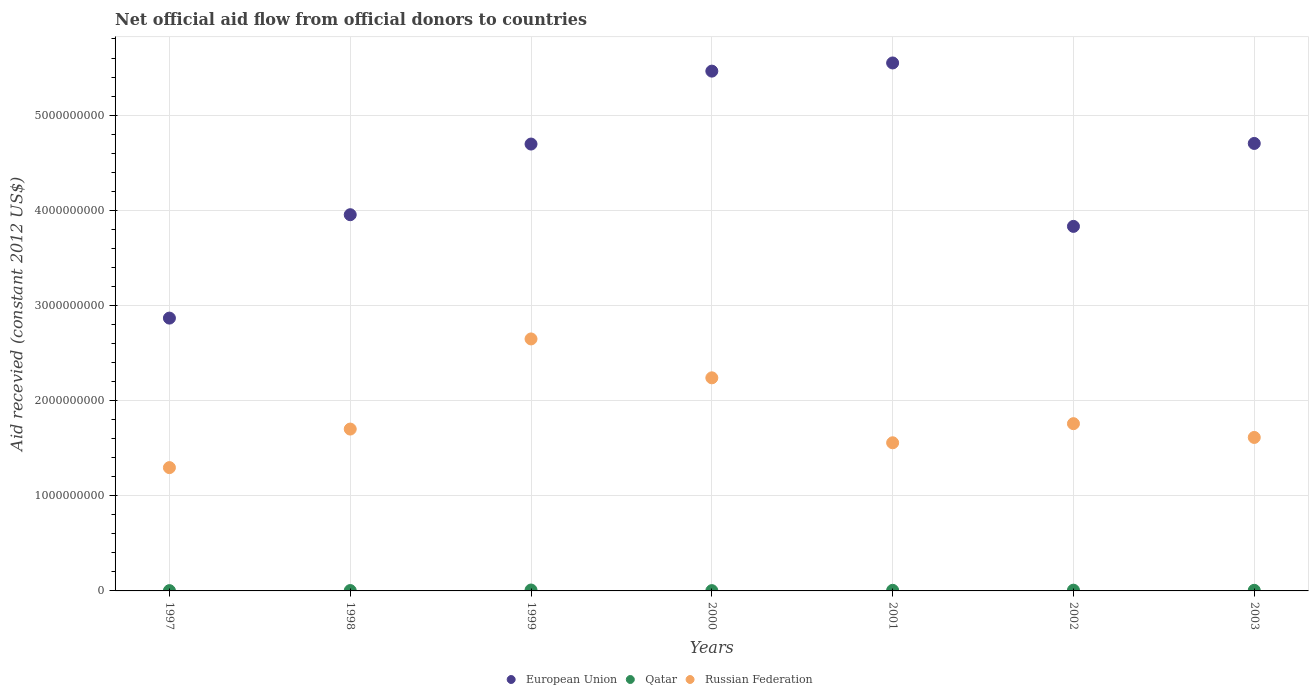What is the total aid received in Qatar in 2000?
Your answer should be compact. 3.14e+06. Across all years, what is the maximum total aid received in Russian Federation?
Provide a succinct answer. 2.65e+09. Across all years, what is the minimum total aid received in European Union?
Offer a very short reply. 2.87e+09. In which year was the total aid received in European Union maximum?
Keep it short and to the point. 2001. In which year was the total aid received in European Union minimum?
Keep it short and to the point. 1997. What is the total total aid received in Russian Federation in the graph?
Your answer should be very brief. 1.28e+1. What is the difference between the total aid received in Qatar in 2002 and that in 2003?
Give a very brief answer. 1.41e+06. What is the difference between the total aid received in Qatar in 1998 and the total aid received in European Union in 2003?
Offer a very short reply. -4.70e+09. What is the average total aid received in Russian Federation per year?
Offer a terse response. 1.83e+09. In the year 2002, what is the difference between the total aid received in European Union and total aid received in Qatar?
Make the answer very short. 3.82e+09. In how many years, is the total aid received in European Union greater than 1600000000 US$?
Provide a short and direct response. 7. What is the ratio of the total aid received in European Union in 1998 to that in 2003?
Provide a succinct answer. 0.84. Is the difference between the total aid received in European Union in 1997 and 1998 greater than the difference between the total aid received in Qatar in 1997 and 1998?
Make the answer very short. No. What is the difference between the highest and the second highest total aid received in European Union?
Offer a very short reply. 8.58e+07. What is the difference between the highest and the lowest total aid received in Qatar?
Provide a short and direct response. 6.53e+06. In how many years, is the total aid received in European Union greater than the average total aid received in European Union taken over all years?
Your response must be concise. 4. Is the sum of the total aid received in Russian Federation in 2001 and 2003 greater than the maximum total aid received in Qatar across all years?
Offer a very short reply. Yes. Does the total aid received in Qatar monotonically increase over the years?
Give a very brief answer. No. Is the total aid received in Russian Federation strictly greater than the total aid received in Qatar over the years?
Keep it short and to the point. Yes. Is the total aid received in Russian Federation strictly less than the total aid received in European Union over the years?
Offer a very short reply. Yes. How many years are there in the graph?
Your answer should be compact. 7. Are the values on the major ticks of Y-axis written in scientific E-notation?
Provide a succinct answer. No. Does the graph contain grids?
Offer a very short reply. Yes. How many legend labels are there?
Ensure brevity in your answer.  3. How are the legend labels stacked?
Your answer should be very brief. Horizontal. What is the title of the graph?
Make the answer very short. Net official aid flow from official donors to countries. What is the label or title of the X-axis?
Keep it short and to the point. Years. What is the label or title of the Y-axis?
Give a very brief answer. Aid recevied (constant 2012 US$). What is the Aid recevied (constant 2012 US$) in European Union in 1997?
Keep it short and to the point. 2.87e+09. What is the Aid recevied (constant 2012 US$) in Qatar in 1997?
Offer a very short reply. 2.98e+06. What is the Aid recevied (constant 2012 US$) in Russian Federation in 1997?
Offer a terse response. 1.30e+09. What is the Aid recevied (constant 2012 US$) of European Union in 1998?
Your response must be concise. 3.95e+09. What is the Aid recevied (constant 2012 US$) of Qatar in 1998?
Provide a succinct answer. 3.90e+06. What is the Aid recevied (constant 2012 US$) in Russian Federation in 1998?
Offer a very short reply. 1.70e+09. What is the Aid recevied (constant 2012 US$) in European Union in 1999?
Provide a succinct answer. 4.70e+09. What is the Aid recevied (constant 2012 US$) in Qatar in 1999?
Keep it short and to the point. 9.51e+06. What is the Aid recevied (constant 2012 US$) of Russian Federation in 1999?
Provide a succinct answer. 2.65e+09. What is the Aid recevied (constant 2012 US$) in European Union in 2000?
Make the answer very short. 5.46e+09. What is the Aid recevied (constant 2012 US$) in Qatar in 2000?
Provide a short and direct response. 3.14e+06. What is the Aid recevied (constant 2012 US$) in Russian Federation in 2000?
Your response must be concise. 2.24e+09. What is the Aid recevied (constant 2012 US$) of European Union in 2001?
Offer a very short reply. 5.55e+09. What is the Aid recevied (constant 2012 US$) of Qatar in 2001?
Your answer should be compact. 6.30e+06. What is the Aid recevied (constant 2012 US$) of Russian Federation in 2001?
Offer a terse response. 1.56e+09. What is the Aid recevied (constant 2012 US$) in European Union in 2002?
Keep it short and to the point. 3.83e+09. What is the Aid recevied (constant 2012 US$) of Qatar in 2002?
Your answer should be very brief. 7.79e+06. What is the Aid recevied (constant 2012 US$) in Russian Federation in 2002?
Your answer should be very brief. 1.76e+09. What is the Aid recevied (constant 2012 US$) of European Union in 2003?
Your answer should be compact. 4.70e+09. What is the Aid recevied (constant 2012 US$) of Qatar in 2003?
Give a very brief answer. 6.38e+06. What is the Aid recevied (constant 2012 US$) of Russian Federation in 2003?
Ensure brevity in your answer.  1.61e+09. Across all years, what is the maximum Aid recevied (constant 2012 US$) of European Union?
Your answer should be very brief. 5.55e+09. Across all years, what is the maximum Aid recevied (constant 2012 US$) in Qatar?
Your response must be concise. 9.51e+06. Across all years, what is the maximum Aid recevied (constant 2012 US$) in Russian Federation?
Keep it short and to the point. 2.65e+09. Across all years, what is the minimum Aid recevied (constant 2012 US$) in European Union?
Your response must be concise. 2.87e+09. Across all years, what is the minimum Aid recevied (constant 2012 US$) of Qatar?
Keep it short and to the point. 2.98e+06. Across all years, what is the minimum Aid recevied (constant 2012 US$) in Russian Federation?
Offer a very short reply. 1.30e+09. What is the total Aid recevied (constant 2012 US$) of European Union in the graph?
Your response must be concise. 3.11e+1. What is the total Aid recevied (constant 2012 US$) of Qatar in the graph?
Offer a very short reply. 4.00e+07. What is the total Aid recevied (constant 2012 US$) in Russian Federation in the graph?
Your answer should be compact. 1.28e+1. What is the difference between the Aid recevied (constant 2012 US$) in European Union in 1997 and that in 1998?
Make the answer very short. -1.09e+09. What is the difference between the Aid recevied (constant 2012 US$) of Qatar in 1997 and that in 1998?
Keep it short and to the point. -9.20e+05. What is the difference between the Aid recevied (constant 2012 US$) in Russian Federation in 1997 and that in 1998?
Your answer should be very brief. -4.05e+08. What is the difference between the Aid recevied (constant 2012 US$) in European Union in 1997 and that in 1999?
Offer a very short reply. -1.83e+09. What is the difference between the Aid recevied (constant 2012 US$) in Qatar in 1997 and that in 1999?
Keep it short and to the point. -6.53e+06. What is the difference between the Aid recevied (constant 2012 US$) of Russian Federation in 1997 and that in 1999?
Give a very brief answer. -1.35e+09. What is the difference between the Aid recevied (constant 2012 US$) of European Union in 1997 and that in 2000?
Keep it short and to the point. -2.60e+09. What is the difference between the Aid recevied (constant 2012 US$) of Qatar in 1997 and that in 2000?
Make the answer very short. -1.60e+05. What is the difference between the Aid recevied (constant 2012 US$) in Russian Federation in 1997 and that in 2000?
Give a very brief answer. -9.44e+08. What is the difference between the Aid recevied (constant 2012 US$) in European Union in 1997 and that in 2001?
Provide a succinct answer. -2.68e+09. What is the difference between the Aid recevied (constant 2012 US$) of Qatar in 1997 and that in 2001?
Your answer should be compact. -3.32e+06. What is the difference between the Aid recevied (constant 2012 US$) of Russian Federation in 1997 and that in 2001?
Your response must be concise. -2.61e+08. What is the difference between the Aid recevied (constant 2012 US$) of European Union in 1997 and that in 2002?
Make the answer very short. -9.64e+08. What is the difference between the Aid recevied (constant 2012 US$) of Qatar in 1997 and that in 2002?
Your response must be concise. -4.81e+06. What is the difference between the Aid recevied (constant 2012 US$) in Russian Federation in 1997 and that in 2002?
Keep it short and to the point. -4.62e+08. What is the difference between the Aid recevied (constant 2012 US$) of European Union in 1997 and that in 2003?
Your answer should be very brief. -1.84e+09. What is the difference between the Aid recevied (constant 2012 US$) in Qatar in 1997 and that in 2003?
Provide a succinct answer. -3.40e+06. What is the difference between the Aid recevied (constant 2012 US$) in Russian Federation in 1997 and that in 2003?
Your answer should be very brief. -3.17e+08. What is the difference between the Aid recevied (constant 2012 US$) in European Union in 1998 and that in 1999?
Offer a very short reply. -7.42e+08. What is the difference between the Aid recevied (constant 2012 US$) in Qatar in 1998 and that in 1999?
Your answer should be very brief. -5.61e+06. What is the difference between the Aid recevied (constant 2012 US$) of Russian Federation in 1998 and that in 1999?
Provide a succinct answer. -9.47e+08. What is the difference between the Aid recevied (constant 2012 US$) in European Union in 1998 and that in 2000?
Provide a succinct answer. -1.51e+09. What is the difference between the Aid recevied (constant 2012 US$) of Qatar in 1998 and that in 2000?
Offer a terse response. 7.60e+05. What is the difference between the Aid recevied (constant 2012 US$) of Russian Federation in 1998 and that in 2000?
Your answer should be very brief. -5.38e+08. What is the difference between the Aid recevied (constant 2012 US$) in European Union in 1998 and that in 2001?
Make the answer very short. -1.59e+09. What is the difference between the Aid recevied (constant 2012 US$) of Qatar in 1998 and that in 2001?
Your answer should be very brief. -2.40e+06. What is the difference between the Aid recevied (constant 2012 US$) in Russian Federation in 1998 and that in 2001?
Give a very brief answer. 1.44e+08. What is the difference between the Aid recevied (constant 2012 US$) in European Union in 1998 and that in 2002?
Give a very brief answer. 1.23e+08. What is the difference between the Aid recevied (constant 2012 US$) in Qatar in 1998 and that in 2002?
Your answer should be compact. -3.89e+06. What is the difference between the Aid recevied (constant 2012 US$) in Russian Federation in 1998 and that in 2002?
Provide a succinct answer. -5.68e+07. What is the difference between the Aid recevied (constant 2012 US$) of European Union in 1998 and that in 2003?
Provide a short and direct response. -7.49e+08. What is the difference between the Aid recevied (constant 2012 US$) in Qatar in 1998 and that in 2003?
Offer a very short reply. -2.48e+06. What is the difference between the Aid recevied (constant 2012 US$) in Russian Federation in 1998 and that in 2003?
Offer a terse response. 8.80e+07. What is the difference between the Aid recevied (constant 2012 US$) in European Union in 1999 and that in 2000?
Provide a succinct answer. -7.66e+08. What is the difference between the Aid recevied (constant 2012 US$) in Qatar in 1999 and that in 2000?
Provide a succinct answer. 6.37e+06. What is the difference between the Aid recevied (constant 2012 US$) of Russian Federation in 1999 and that in 2000?
Your response must be concise. 4.09e+08. What is the difference between the Aid recevied (constant 2012 US$) of European Union in 1999 and that in 2001?
Your response must be concise. -8.52e+08. What is the difference between the Aid recevied (constant 2012 US$) of Qatar in 1999 and that in 2001?
Give a very brief answer. 3.21e+06. What is the difference between the Aid recevied (constant 2012 US$) in Russian Federation in 1999 and that in 2001?
Keep it short and to the point. 1.09e+09. What is the difference between the Aid recevied (constant 2012 US$) of European Union in 1999 and that in 2002?
Make the answer very short. 8.65e+08. What is the difference between the Aid recevied (constant 2012 US$) in Qatar in 1999 and that in 2002?
Offer a very short reply. 1.72e+06. What is the difference between the Aid recevied (constant 2012 US$) of Russian Federation in 1999 and that in 2002?
Ensure brevity in your answer.  8.90e+08. What is the difference between the Aid recevied (constant 2012 US$) of European Union in 1999 and that in 2003?
Offer a very short reply. -6.37e+06. What is the difference between the Aid recevied (constant 2012 US$) of Qatar in 1999 and that in 2003?
Offer a very short reply. 3.13e+06. What is the difference between the Aid recevied (constant 2012 US$) of Russian Federation in 1999 and that in 2003?
Provide a short and direct response. 1.04e+09. What is the difference between the Aid recevied (constant 2012 US$) in European Union in 2000 and that in 2001?
Ensure brevity in your answer.  -8.58e+07. What is the difference between the Aid recevied (constant 2012 US$) in Qatar in 2000 and that in 2001?
Provide a short and direct response. -3.16e+06. What is the difference between the Aid recevied (constant 2012 US$) of Russian Federation in 2000 and that in 2001?
Provide a succinct answer. 6.83e+08. What is the difference between the Aid recevied (constant 2012 US$) of European Union in 2000 and that in 2002?
Make the answer very short. 1.63e+09. What is the difference between the Aid recevied (constant 2012 US$) of Qatar in 2000 and that in 2002?
Offer a very short reply. -4.65e+06. What is the difference between the Aid recevied (constant 2012 US$) in Russian Federation in 2000 and that in 2002?
Your answer should be compact. 4.82e+08. What is the difference between the Aid recevied (constant 2012 US$) in European Union in 2000 and that in 2003?
Ensure brevity in your answer.  7.60e+08. What is the difference between the Aid recevied (constant 2012 US$) in Qatar in 2000 and that in 2003?
Provide a short and direct response. -3.24e+06. What is the difference between the Aid recevied (constant 2012 US$) in Russian Federation in 2000 and that in 2003?
Offer a very short reply. 6.26e+08. What is the difference between the Aid recevied (constant 2012 US$) in European Union in 2001 and that in 2002?
Offer a terse response. 1.72e+09. What is the difference between the Aid recevied (constant 2012 US$) of Qatar in 2001 and that in 2002?
Make the answer very short. -1.49e+06. What is the difference between the Aid recevied (constant 2012 US$) of Russian Federation in 2001 and that in 2002?
Keep it short and to the point. -2.01e+08. What is the difference between the Aid recevied (constant 2012 US$) in European Union in 2001 and that in 2003?
Offer a terse response. 8.46e+08. What is the difference between the Aid recevied (constant 2012 US$) in Qatar in 2001 and that in 2003?
Provide a short and direct response. -8.00e+04. What is the difference between the Aid recevied (constant 2012 US$) in Russian Federation in 2001 and that in 2003?
Your answer should be compact. -5.60e+07. What is the difference between the Aid recevied (constant 2012 US$) in European Union in 2002 and that in 2003?
Keep it short and to the point. -8.71e+08. What is the difference between the Aid recevied (constant 2012 US$) of Qatar in 2002 and that in 2003?
Make the answer very short. 1.41e+06. What is the difference between the Aid recevied (constant 2012 US$) in Russian Federation in 2002 and that in 2003?
Your answer should be very brief. 1.45e+08. What is the difference between the Aid recevied (constant 2012 US$) of European Union in 1997 and the Aid recevied (constant 2012 US$) of Qatar in 1998?
Offer a terse response. 2.86e+09. What is the difference between the Aid recevied (constant 2012 US$) of European Union in 1997 and the Aid recevied (constant 2012 US$) of Russian Federation in 1998?
Make the answer very short. 1.17e+09. What is the difference between the Aid recevied (constant 2012 US$) in Qatar in 1997 and the Aid recevied (constant 2012 US$) in Russian Federation in 1998?
Make the answer very short. -1.70e+09. What is the difference between the Aid recevied (constant 2012 US$) in European Union in 1997 and the Aid recevied (constant 2012 US$) in Qatar in 1999?
Make the answer very short. 2.86e+09. What is the difference between the Aid recevied (constant 2012 US$) of European Union in 1997 and the Aid recevied (constant 2012 US$) of Russian Federation in 1999?
Offer a terse response. 2.19e+08. What is the difference between the Aid recevied (constant 2012 US$) in Qatar in 1997 and the Aid recevied (constant 2012 US$) in Russian Federation in 1999?
Give a very brief answer. -2.64e+09. What is the difference between the Aid recevied (constant 2012 US$) of European Union in 1997 and the Aid recevied (constant 2012 US$) of Qatar in 2000?
Keep it short and to the point. 2.86e+09. What is the difference between the Aid recevied (constant 2012 US$) of European Union in 1997 and the Aid recevied (constant 2012 US$) of Russian Federation in 2000?
Give a very brief answer. 6.28e+08. What is the difference between the Aid recevied (constant 2012 US$) of Qatar in 1997 and the Aid recevied (constant 2012 US$) of Russian Federation in 2000?
Give a very brief answer. -2.24e+09. What is the difference between the Aid recevied (constant 2012 US$) of European Union in 1997 and the Aid recevied (constant 2012 US$) of Qatar in 2001?
Provide a succinct answer. 2.86e+09. What is the difference between the Aid recevied (constant 2012 US$) in European Union in 1997 and the Aid recevied (constant 2012 US$) in Russian Federation in 2001?
Provide a succinct answer. 1.31e+09. What is the difference between the Aid recevied (constant 2012 US$) of Qatar in 1997 and the Aid recevied (constant 2012 US$) of Russian Federation in 2001?
Keep it short and to the point. -1.55e+09. What is the difference between the Aid recevied (constant 2012 US$) in European Union in 1997 and the Aid recevied (constant 2012 US$) in Qatar in 2002?
Your response must be concise. 2.86e+09. What is the difference between the Aid recevied (constant 2012 US$) of European Union in 1997 and the Aid recevied (constant 2012 US$) of Russian Federation in 2002?
Make the answer very short. 1.11e+09. What is the difference between the Aid recevied (constant 2012 US$) in Qatar in 1997 and the Aid recevied (constant 2012 US$) in Russian Federation in 2002?
Your answer should be very brief. -1.75e+09. What is the difference between the Aid recevied (constant 2012 US$) of European Union in 1997 and the Aid recevied (constant 2012 US$) of Qatar in 2003?
Offer a very short reply. 2.86e+09. What is the difference between the Aid recevied (constant 2012 US$) in European Union in 1997 and the Aid recevied (constant 2012 US$) in Russian Federation in 2003?
Make the answer very short. 1.25e+09. What is the difference between the Aid recevied (constant 2012 US$) of Qatar in 1997 and the Aid recevied (constant 2012 US$) of Russian Federation in 2003?
Offer a very short reply. -1.61e+09. What is the difference between the Aid recevied (constant 2012 US$) of European Union in 1998 and the Aid recevied (constant 2012 US$) of Qatar in 1999?
Provide a short and direct response. 3.94e+09. What is the difference between the Aid recevied (constant 2012 US$) in European Union in 1998 and the Aid recevied (constant 2012 US$) in Russian Federation in 1999?
Give a very brief answer. 1.31e+09. What is the difference between the Aid recevied (constant 2012 US$) in Qatar in 1998 and the Aid recevied (constant 2012 US$) in Russian Federation in 1999?
Provide a short and direct response. -2.64e+09. What is the difference between the Aid recevied (constant 2012 US$) in European Union in 1998 and the Aid recevied (constant 2012 US$) in Qatar in 2000?
Keep it short and to the point. 3.95e+09. What is the difference between the Aid recevied (constant 2012 US$) of European Union in 1998 and the Aid recevied (constant 2012 US$) of Russian Federation in 2000?
Your response must be concise. 1.71e+09. What is the difference between the Aid recevied (constant 2012 US$) of Qatar in 1998 and the Aid recevied (constant 2012 US$) of Russian Federation in 2000?
Offer a terse response. -2.24e+09. What is the difference between the Aid recevied (constant 2012 US$) in European Union in 1998 and the Aid recevied (constant 2012 US$) in Qatar in 2001?
Your answer should be compact. 3.95e+09. What is the difference between the Aid recevied (constant 2012 US$) in European Union in 1998 and the Aid recevied (constant 2012 US$) in Russian Federation in 2001?
Your answer should be compact. 2.40e+09. What is the difference between the Aid recevied (constant 2012 US$) of Qatar in 1998 and the Aid recevied (constant 2012 US$) of Russian Federation in 2001?
Offer a terse response. -1.55e+09. What is the difference between the Aid recevied (constant 2012 US$) in European Union in 1998 and the Aid recevied (constant 2012 US$) in Qatar in 2002?
Your response must be concise. 3.95e+09. What is the difference between the Aid recevied (constant 2012 US$) in European Union in 1998 and the Aid recevied (constant 2012 US$) in Russian Federation in 2002?
Your answer should be compact. 2.20e+09. What is the difference between the Aid recevied (constant 2012 US$) of Qatar in 1998 and the Aid recevied (constant 2012 US$) of Russian Federation in 2002?
Ensure brevity in your answer.  -1.75e+09. What is the difference between the Aid recevied (constant 2012 US$) in European Union in 1998 and the Aid recevied (constant 2012 US$) in Qatar in 2003?
Offer a terse response. 3.95e+09. What is the difference between the Aid recevied (constant 2012 US$) of European Union in 1998 and the Aid recevied (constant 2012 US$) of Russian Federation in 2003?
Your answer should be compact. 2.34e+09. What is the difference between the Aid recevied (constant 2012 US$) in Qatar in 1998 and the Aid recevied (constant 2012 US$) in Russian Federation in 2003?
Keep it short and to the point. -1.61e+09. What is the difference between the Aid recevied (constant 2012 US$) in European Union in 1999 and the Aid recevied (constant 2012 US$) in Qatar in 2000?
Offer a terse response. 4.69e+09. What is the difference between the Aid recevied (constant 2012 US$) of European Union in 1999 and the Aid recevied (constant 2012 US$) of Russian Federation in 2000?
Provide a short and direct response. 2.46e+09. What is the difference between the Aid recevied (constant 2012 US$) in Qatar in 1999 and the Aid recevied (constant 2012 US$) in Russian Federation in 2000?
Your answer should be very brief. -2.23e+09. What is the difference between the Aid recevied (constant 2012 US$) in European Union in 1999 and the Aid recevied (constant 2012 US$) in Qatar in 2001?
Keep it short and to the point. 4.69e+09. What is the difference between the Aid recevied (constant 2012 US$) of European Union in 1999 and the Aid recevied (constant 2012 US$) of Russian Federation in 2001?
Your answer should be compact. 3.14e+09. What is the difference between the Aid recevied (constant 2012 US$) in Qatar in 1999 and the Aid recevied (constant 2012 US$) in Russian Federation in 2001?
Your response must be concise. -1.55e+09. What is the difference between the Aid recevied (constant 2012 US$) of European Union in 1999 and the Aid recevied (constant 2012 US$) of Qatar in 2002?
Offer a terse response. 4.69e+09. What is the difference between the Aid recevied (constant 2012 US$) of European Union in 1999 and the Aid recevied (constant 2012 US$) of Russian Federation in 2002?
Give a very brief answer. 2.94e+09. What is the difference between the Aid recevied (constant 2012 US$) in Qatar in 1999 and the Aid recevied (constant 2012 US$) in Russian Federation in 2002?
Provide a short and direct response. -1.75e+09. What is the difference between the Aid recevied (constant 2012 US$) of European Union in 1999 and the Aid recevied (constant 2012 US$) of Qatar in 2003?
Your response must be concise. 4.69e+09. What is the difference between the Aid recevied (constant 2012 US$) in European Union in 1999 and the Aid recevied (constant 2012 US$) in Russian Federation in 2003?
Provide a short and direct response. 3.08e+09. What is the difference between the Aid recevied (constant 2012 US$) in Qatar in 1999 and the Aid recevied (constant 2012 US$) in Russian Federation in 2003?
Your response must be concise. -1.60e+09. What is the difference between the Aid recevied (constant 2012 US$) in European Union in 2000 and the Aid recevied (constant 2012 US$) in Qatar in 2001?
Make the answer very short. 5.46e+09. What is the difference between the Aid recevied (constant 2012 US$) of European Union in 2000 and the Aid recevied (constant 2012 US$) of Russian Federation in 2001?
Ensure brevity in your answer.  3.91e+09. What is the difference between the Aid recevied (constant 2012 US$) in Qatar in 2000 and the Aid recevied (constant 2012 US$) in Russian Federation in 2001?
Offer a very short reply. -1.55e+09. What is the difference between the Aid recevied (constant 2012 US$) in European Union in 2000 and the Aid recevied (constant 2012 US$) in Qatar in 2002?
Your answer should be compact. 5.45e+09. What is the difference between the Aid recevied (constant 2012 US$) in European Union in 2000 and the Aid recevied (constant 2012 US$) in Russian Federation in 2002?
Your answer should be compact. 3.70e+09. What is the difference between the Aid recevied (constant 2012 US$) in Qatar in 2000 and the Aid recevied (constant 2012 US$) in Russian Federation in 2002?
Give a very brief answer. -1.75e+09. What is the difference between the Aid recevied (constant 2012 US$) in European Union in 2000 and the Aid recevied (constant 2012 US$) in Qatar in 2003?
Keep it short and to the point. 5.46e+09. What is the difference between the Aid recevied (constant 2012 US$) of European Union in 2000 and the Aid recevied (constant 2012 US$) of Russian Federation in 2003?
Keep it short and to the point. 3.85e+09. What is the difference between the Aid recevied (constant 2012 US$) in Qatar in 2000 and the Aid recevied (constant 2012 US$) in Russian Federation in 2003?
Your answer should be very brief. -1.61e+09. What is the difference between the Aid recevied (constant 2012 US$) of European Union in 2001 and the Aid recevied (constant 2012 US$) of Qatar in 2002?
Provide a short and direct response. 5.54e+09. What is the difference between the Aid recevied (constant 2012 US$) in European Union in 2001 and the Aid recevied (constant 2012 US$) in Russian Federation in 2002?
Your response must be concise. 3.79e+09. What is the difference between the Aid recevied (constant 2012 US$) of Qatar in 2001 and the Aid recevied (constant 2012 US$) of Russian Federation in 2002?
Offer a very short reply. -1.75e+09. What is the difference between the Aid recevied (constant 2012 US$) of European Union in 2001 and the Aid recevied (constant 2012 US$) of Qatar in 2003?
Your answer should be compact. 5.54e+09. What is the difference between the Aid recevied (constant 2012 US$) of European Union in 2001 and the Aid recevied (constant 2012 US$) of Russian Federation in 2003?
Your response must be concise. 3.94e+09. What is the difference between the Aid recevied (constant 2012 US$) in Qatar in 2001 and the Aid recevied (constant 2012 US$) in Russian Federation in 2003?
Provide a short and direct response. -1.61e+09. What is the difference between the Aid recevied (constant 2012 US$) of European Union in 2002 and the Aid recevied (constant 2012 US$) of Qatar in 2003?
Offer a terse response. 3.82e+09. What is the difference between the Aid recevied (constant 2012 US$) of European Union in 2002 and the Aid recevied (constant 2012 US$) of Russian Federation in 2003?
Your answer should be very brief. 2.22e+09. What is the difference between the Aid recevied (constant 2012 US$) of Qatar in 2002 and the Aid recevied (constant 2012 US$) of Russian Federation in 2003?
Offer a terse response. -1.60e+09. What is the average Aid recevied (constant 2012 US$) of European Union per year?
Your answer should be compact. 4.44e+09. What is the average Aid recevied (constant 2012 US$) in Qatar per year?
Provide a succinct answer. 5.71e+06. What is the average Aid recevied (constant 2012 US$) of Russian Federation per year?
Your answer should be very brief. 1.83e+09. In the year 1997, what is the difference between the Aid recevied (constant 2012 US$) of European Union and Aid recevied (constant 2012 US$) of Qatar?
Give a very brief answer. 2.86e+09. In the year 1997, what is the difference between the Aid recevied (constant 2012 US$) of European Union and Aid recevied (constant 2012 US$) of Russian Federation?
Provide a short and direct response. 1.57e+09. In the year 1997, what is the difference between the Aid recevied (constant 2012 US$) of Qatar and Aid recevied (constant 2012 US$) of Russian Federation?
Offer a terse response. -1.29e+09. In the year 1998, what is the difference between the Aid recevied (constant 2012 US$) in European Union and Aid recevied (constant 2012 US$) in Qatar?
Make the answer very short. 3.95e+09. In the year 1998, what is the difference between the Aid recevied (constant 2012 US$) in European Union and Aid recevied (constant 2012 US$) in Russian Federation?
Give a very brief answer. 2.25e+09. In the year 1998, what is the difference between the Aid recevied (constant 2012 US$) in Qatar and Aid recevied (constant 2012 US$) in Russian Federation?
Keep it short and to the point. -1.70e+09. In the year 1999, what is the difference between the Aid recevied (constant 2012 US$) in European Union and Aid recevied (constant 2012 US$) in Qatar?
Ensure brevity in your answer.  4.69e+09. In the year 1999, what is the difference between the Aid recevied (constant 2012 US$) of European Union and Aid recevied (constant 2012 US$) of Russian Federation?
Your answer should be compact. 2.05e+09. In the year 1999, what is the difference between the Aid recevied (constant 2012 US$) of Qatar and Aid recevied (constant 2012 US$) of Russian Federation?
Provide a short and direct response. -2.64e+09. In the year 2000, what is the difference between the Aid recevied (constant 2012 US$) in European Union and Aid recevied (constant 2012 US$) in Qatar?
Your answer should be compact. 5.46e+09. In the year 2000, what is the difference between the Aid recevied (constant 2012 US$) of European Union and Aid recevied (constant 2012 US$) of Russian Federation?
Ensure brevity in your answer.  3.22e+09. In the year 2000, what is the difference between the Aid recevied (constant 2012 US$) in Qatar and Aid recevied (constant 2012 US$) in Russian Federation?
Your answer should be compact. -2.24e+09. In the year 2001, what is the difference between the Aid recevied (constant 2012 US$) of European Union and Aid recevied (constant 2012 US$) of Qatar?
Your answer should be very brief. 5.54e+09. In the year 2001, what is the difference between the Aid recevied (constant 2012 US$) in European Union and Aid recevied (constant 2012 US$) in Russian Federation?
Ensure brevity in your answer.  3.99e+09. In the year 2001, what is the difference between the Aid recevied (constant 2012 US$) of Qatar and Aid recevied (constant 2012 US$) of Russian Federation?
Your response must be concise. -1.55e+09. In the year 2002, what is the difference between the Aid recevied (constant 2012 US$) in European Union and Aid recevied (constant 2012 US$) in Qatar?
Make the answer very short. 3.82e+09. In the year 2002, what is the difference between the Aid recevied (constant 2012 US$) of European Union and Aid recevied (constant 2012 US$) of Russian Federation?
Make the answer very short. 2.07e+09. In the year 2002, what is the difference between the Aid recevied (constant 2012 US$) in Qatar and Aid recevied (constant 2012 US$) in Russian Federation?
Offer a terse response. -1.75e+09. In the year 2003, what is the difference between the Aid recevied (constant 2012 US$) in European Union and Aid recevied (constant 2012 US$) in Qatar?
Your answer should be compact. 4.70e+09. In the year 2003, what is the difference between the Aid recevied (constant 2012 US$) of European Union and Aid recevied (constant 2012 US$) of Russian Federation?
Your answer should be compact. 3.09e+09. In the year 2003, what is the difference between the Aid recevied (constant 2012 US$) of Qatar and Aid recevied (constant 2012 US$) of Russian Federation?
Your answer should be very brief. -1.61e+09. What is the ratio of the Aid recevied (constant 2012 US$) of European Union in 1997 to that in 1998?
Give a very brief answer. 0.73. What is the ratio of the Aid recevied (constant 2012 US$) of Qatar in 1997 to that in 1998?
Provide a short and direct response. 0.76. What is the ratio of the Aid recevied (constant 2012 US$) in Russian Federation in 1997 to that in 1998?
Ensure brevity in your answer.  0.76. What is the ratio of the Aid recevied (constant 2012 US$) in European Union in 1997 to that in 1999?
Provide a succinct answer. 0.61. What is the ratio of the Aid recevied (constant 2012 US$) of Qatar in 1997 to that in 1999?
Make the answer very short. 0.31. What is the ratio of the Aid recevied (constant 2012 US$) in Russian Federation in 1997 to that in 1999?
Make the answer very short. 0.49. What is the ratio of the Aid recevied (constant 2012 US$) of European Union in 1997 to that in 2000?
Ensure brevity in your answer.  0.52. What is the ratio of the Aid recevied (constant 2012 US$) of Qatar in 1997 to that in 2000?
Offer a very short reply. 0.95. What is the ratio of the Aid recevied (constant 2012 US$) in Russian Federation in 1997 to that in 2000?
Your response must be concise. 0.58. What is the ratio of the Aid recevied (constant 2012 US$) in European Union in 1997 to that in 2001?
Provide a succinct answer. 0.52. What is the ratio of the Aid recevied (constant 2012 US$) in Qatar in 1997 to that in 2001?
Your answer should be very brief. 0.47. What is the ratio of the Aid recevied (constant 2012 US$) of Russian Federation in 1997 to that in 2001?
Provide a short and direct response. 0.83. What is the ratio of the Aid recevied (constant 2012 US$) of European Union in 1997 to that in 2002?
Offer a very short reply. 0.75. What is the ratio of the Aid recevied (constant 2012 US$) of Qatar in 1997 to that in 2002?
Your response must be concise. 0.38. What is the ratio of the Aid recevied (constant 2012 US$) in Russian Federation in 1997 to that in 2002?
Provide a short and direct response. 0.74. What is the ratio of the Aid recevied (constant 2012 US$) in European Union in 1997 to that in 2003?
Your answer should be compact. 0.61. What is the ratio of the Aid recevied (constant 2012 US$) in Qatar in 1997 to that in 2003?
Offer a terse response. 0.47. What is the ratio of the Aid recevied (constant 2012 US$) in Russian Federation in 1997 to that in 2003?
Keep it short and to the point. 0.8. What is the ratio of the Aid recevied (constant 2012 US$) in European Union in 1998 to that in 1999?
Give a very brief answer. 0.84. What is the ratio of the Aid recevied (constant 2012 US$) of Qatar in 1998 to that in 1999?
Provide a succinct answer. 0.41. What is the ratio of the Aid recevied (constant 2012 US$) in Russian Federation in 1998 to that in 1999?
Offer a terse response. 0.64. What is the ratio of the Aid recevied (constant 2012 US$) of European Union in 1998 to that in 2000?
Your answer should be very brief. 0.72. What is the ratio of the Aid recevied (constant 2012 US$) in Qatar in 1998 to that in 2000?
Provide a short and direct response. 1.24. What is the ratio of the Aid recevied (constant 2012 US$) in Russian Federation in 1998 to that in 2000?
Give a very brief answer. 0.76. What is the ratio of the Aid recevied (constant 2012 US$) of European Union in 1998 to that in 2001?
Make the answer very short. 0.71. What is the ratio of the Aid recevied (constant 2012 US$) in Qatar in 1998 to that in 2001?
Your response must be concise. 0.62. What is the ratio of the Aid recevied (constant 2012 US$) of Russian Federation in 1998 to that in 2001?
Give a very brief answer. 1.09. What is the ratio of the Aid recevied (constant 2012 US$) of European Union in 1998 to that in 2002?
Provide a short and direct response. 1.03. What is the ratio of the Aid recevied (constant 2012 US$) of Qatar in 1998 to that in 2002?
Your response must be concise. 0.5. What is the ratio of the Aid recevied (constant 2012 US$) in Russian Federation in 1998 to that in 2002?
Ensure brevity in your answer.  0.97. What is the ratio of the Aid recevied (constant 2012 US$) in European Union in 1998 to that in 2003?
Keep it short and to the point. 0.84. What is the ratio of the Aid recevied (constant 2012 US$) of Qatar in 1998 to that in 2003?
Your response must be concise. 0.61. What is the ratio of the Aid recevied (constant 2012 US$) in Russian Federation in 1998 to that in 2003?
Keep it short and to the point. 1.05. What is the ratio of the Aid recevied (constant 2012 US$) of European Union in 1999 to that in 2000?
Your answer should be compact. 0.86. What is the ratio of the Aid recevied (constant 2012 US$) in Qatar in 1999 to that in 2000?
Offer a terse response. 3.03. What is the ratio of the Aid recevied (constant 2012 US$) of Russian Federation in 1999 to that in 2000?
Make the answer very short. 1.18. What is the ratio of the Aid recevied (constant 2012 US$) in European Union in 1999 to that in 2001?
Provide a short and direct response. 0.85. What is the ratio of the Aid recevied (constant 2012 US$) of Qatar in 1999 to that in 2001?
Give a very brief answer. 1.51. What is the ratio of the Aid recevied (constant 2012 US$) in Russian Federation in 1999 to that in 2001?
Your answer should be very brief. 1.7. What is the ratio of the Aid recevied (constant 2012 US$) in European Union in 1999 to that in 2002?
Ensure brevity in your answer.  1.23. What is the ratio of the Aid recevied (constant 2012 US$) in Qatar in 1999 to that in 2002?
Your answer should be compact. 1.22. What is the ratio of the Aid recevied (constant 2012 US$) in Russian Federation in 1999 to that in 2002?
Offer a terse response. 1.51. What is the ratio of the Aid recevied (constant 2012 US$) of Qatar in 1999 to that in 2003?
Offer a very short reply. 1.49. What is the ratio of the Aid recevied (constant 2012 US$) of Russian Federation in 1999 to that in 2003?
Offer a terse response. 1.64. What is the ratio of the Aid recevied (constant 2012 US$) of European Union in 2000 to that in 2001?
Provide a succinct answer. 0.98. What is the ratio of the Aid recevied (constant 2012 US$) of Qatar in 2000 to that in 2001?
Ensure brevity in your answer.  0.5. What is the ratio of the Aid recevied (constant 2012 US$) in Russian Federation in 2000 to that in 2001?
Give a very brief answer. 1.44. What is the ratio of the Aid recevied (constant 2012 US$) of European Union in 2000 to that in 2002?
Your answer should be very brief. 1.43. What is the ratio of the Aid recevied (constant 2012 US$) in Qatar in 2000 to that in 2002?
Your answer should be very brief. 0.4. What is the ratio of the Aid recevied (constant 2012 US$) of Russian Federation in 2000 to that in 2002?
Offer a terse response. 1.27. What is the ratio of the Aid recevied (constant 2012 US$) of European Union in 2000 to that in 2003?
Keep it short and to the point. 1.16. What is the ratio of the Aid recevied (constant 2012 US$) of Qatar in 2000 to that in 2003?
Your answer should be compact. 0.49. What is the ratio of the Aid recevied (constant 2012 US$) in Russian Federation in 2000 to that in 2003?
Keep it short and to the point. 1.39. What is the ratio of the Aid recevied (constant 2012 US$) in European Union in 2001 to that in 2002?
Offer a very short reply. 1.45. What is the ratio of the Aid recevied (constant 2012 US$) in Qatar in 2001 to that in 2002?
Your answer should be very brief. 0.81. What is the ratio of the Aid recevied (constant 2012 US$) of Russian Federation in 2001 to that in 2002?
Provide a succinct answer. 0.89. What is the ratio of the Aid recevied (constant 2012 US$) of European Union in 2001 to that in 2003?
Your answer should be very brief. 1.18. What is the ratio of the Aid recevied (constant 2012 US$) in Qatar in 2001 to that in 2003?
Offer a very short reply. 0.99. What is the ratio of the Aid recevied (constant 2012 US$) in Russian Federation in 2001 to that in 2003?
Your answer should be compact. 0.97. What is the ratio of the Aid recevied (constant 2012 US$) in European Union in 2002 to that in 2003?
Your answer should be compact. 0.81. What is the ratio of the Aid recevied (constant 2012 US$) of Qatar in 2002 to that in 2003?
Your answer should be compact. 1.22. What is the ratio of the Aid recevied (constant 2012 US$) of Russian Federation in 2002 to that in 2003?
Your response must be concise. 1.09. What is the difference between the highest and the second highest Aid recevied (constant 2012 US$) of European Union?
Offer a very short reply. 8.58e+07. What is the difference between the highest and the second highest Aid recevied (constant 2012 US$) of Qatar?
Your response must be concise. 1.72e+06. What is the difference between the highest and the second highest Aid recevied (constant 2012 US$) of Russian Federation?
Keep it short and to the point. 4.09e+08. What is the difference between the highest and the lowest Aid recevied (constant 2012 US$) of European Union?
Give a very brief answer. 2.68e+09. What is the difference between the highest and the lowest Aid recevied (constant 2012 US$) of Qatar?
Provide a succinct answer. 6.53e+06. What is the difference between the highest and the lowest Aid recevied (constant 2012 US$) of Russian Federation?
Offer a terse response. 1.35e+09. 